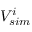<formula> <loc_0><loc_0><loc_500><loc_500>V _ { s i m } ^ { i }</formula> 